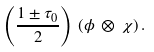Convert formula to latex. <formula><loc_0><loc_0><loc_500><loc_500>\left ( \frac { 1 \pm \tau _ { 0 } } { 2 } \right ) \, ( \phi \, \otimes \, \chi ) \, .</formula> 